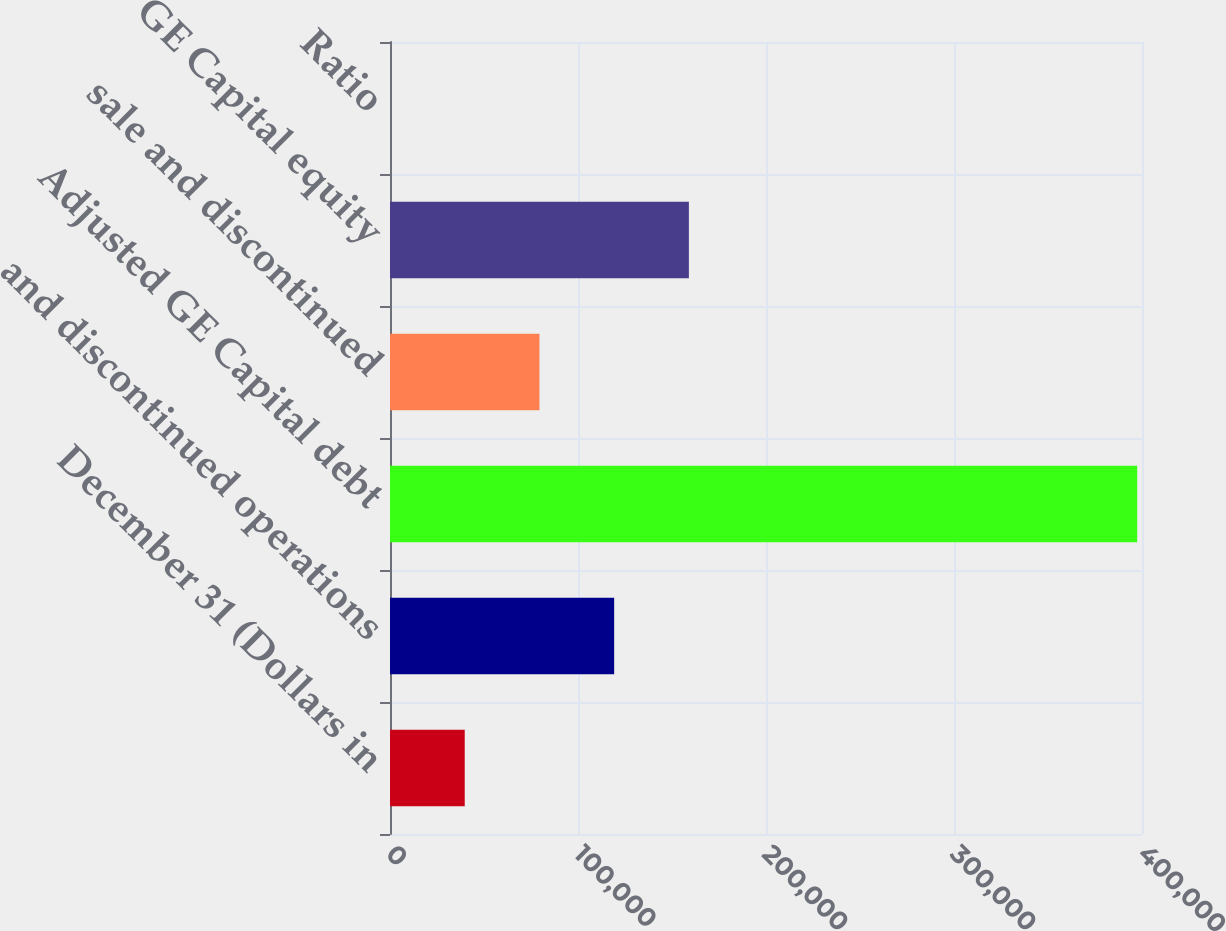Convert chart. <chart><loc_0><loc_0><loc_500><loc_500><bar_chart><fcel>December 31 (Dollars in<fcel>and discontinued operations<fcel>Adjusted GE Capital debt<fcel>sale and discontinued<fcel>GE Capital equity<fcel>Ratio<nl><fcel>39747.9<fcel>119235<fcel>397442<fcel>79491.7<fcel>158979<fcel>4.09<nl></chart> 